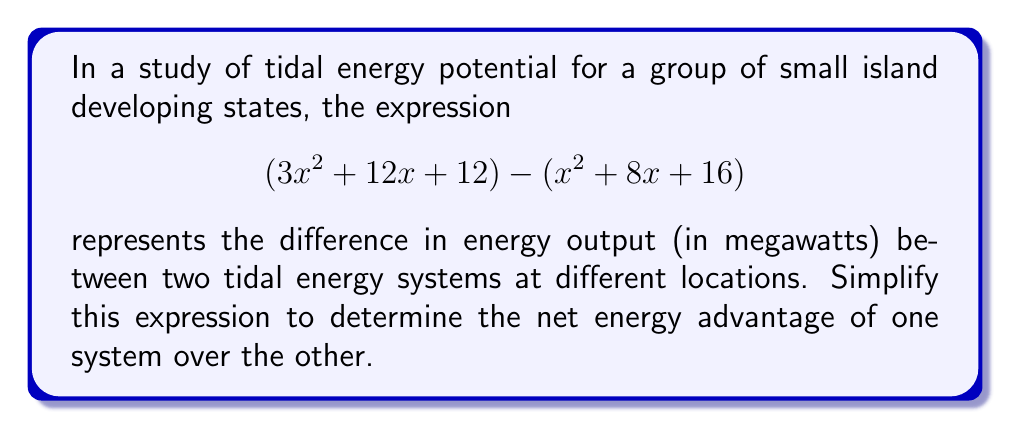Can you answer this question? To simplify this expression, we'll subtract the second polynomial from the first:

1) First, let's arrange the polynomials:
   $$(3x^2 + 12x + 12) - (x^2 + 8x + 16)$$

2) When subtracting polynomials, we subtract the coefficients of like terms:

   For $x^2$ terms: $3x^2 - x^2 = 2x^2$
   For $x$ terms: $12x - 8x = 4x$
   For constant terms: $12 - 16 = -4$

3) Combining these results:
   $$2x^2 + 4x - 4$$

4) This expression cannot be factored further, so this is our simplified form.

This simplified expression represents the net energy advantage (in megawatts) of one tidal energy system over the other as a function of the variable $x$, which could represent a factor such as tidal range or current speed.
Answer: $$2x^2 + 4x - 4$$ 